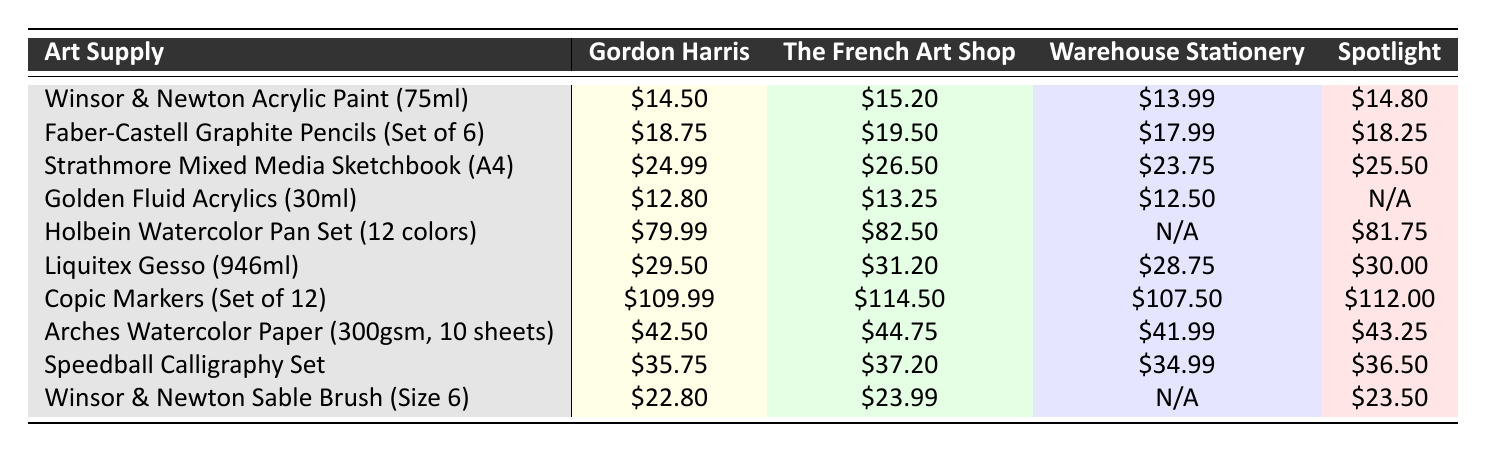What is the price of Winsor & Newton Acrylic Paint at Warehouse Stationery? Looking at the row for Winsor & Newton Acrylic Paint, I can see that the price at Warehouse Stationery is listed as $13.99.
Answer: $13.99 Which retailer offers the most expensive Copic Markers? Upon reviewing the prices for Copic Markers across the retailers, The French Art Shop has the highest price at $114.50.
Answer: The French Art Shop What is the average price of the Liquitex Gesso across the retailers? The prices for Liquitex Gesso are $29.50, $31.20, $28.75, and $30.00. Summing these gives $29.50 + $31.20 + $28.75 + $30.00 = $119.45. Dividing by the number of retailers (4), the average is $119.45 / 4 = $29.86.
Answer: $29.86 Is the Golden Fluid Acrylics available at Spotlight? Checking the row for Golden Fluid Acrylics, the entry for Spotlight is marked as N/A, indicating it is not available.
Answer: No What is the price difference between the Strathmore Mixed Media Sketchbook at Gordon Harris and at Warehouse Stationery? The prices are $24.99 at Gordon Harris and $23.75 at Warehouse Stationery. The difference is calculated as $24.99 - $23.75, which equals $1.24.
Answer: $1.24 